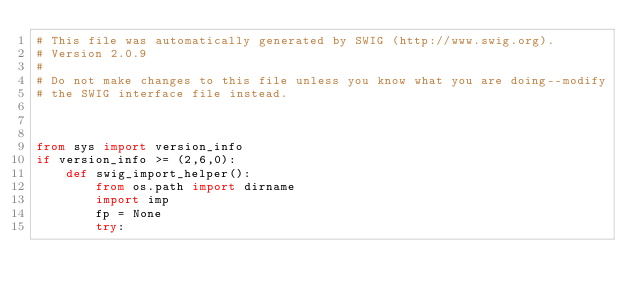Convert code to text. <code><loc_0><loc_0><loc_500><loc_500><_Python_># This file was automatically generated by SWIG (http://www.swig.org).
# Version 2.0.9
#
# Do not make changes to this file unless you know what you are doing--modify
# the SWIG interface file instead.



from sys import version_info
if version_info >= (2,6,0):
    def swig_import_helper():
        from os.path import dirname
        import imp
        fp = None
        try:</code> 